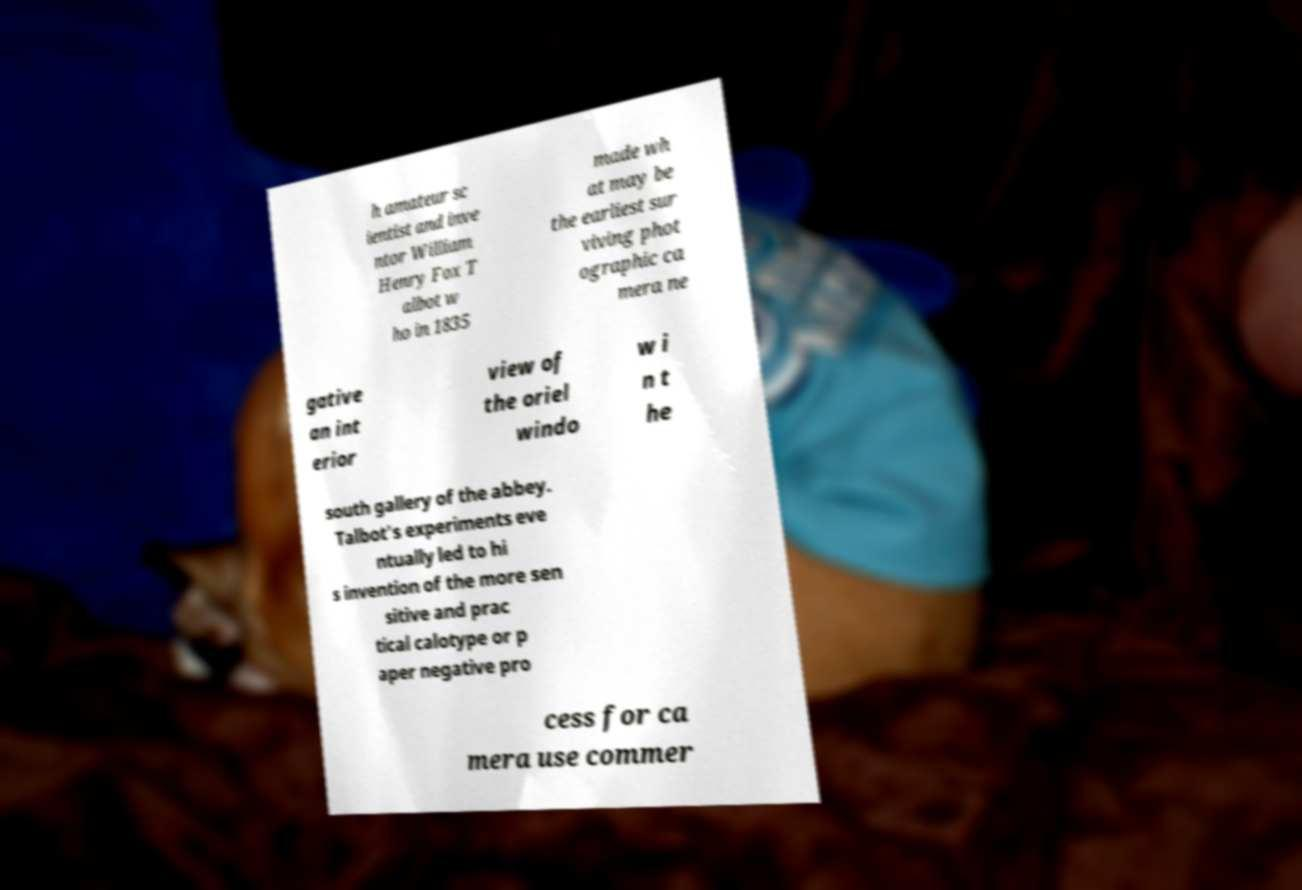For documentation purposes, I need the text within this image transcribed. Could you provide that? h amateur sc ientist and inve ntor William Henry Fox T albot w ho in 1835 made wh at may be the earliest sur viving phot ographic ca mera ne gative an int erior view of the oriel windo w i n t he south gallery of the abbey. Talbot's experiments eve ntually led to hi s invention of the more sen sitive and prac tical calotype or p aper negative pro cess for ca mera use commer 